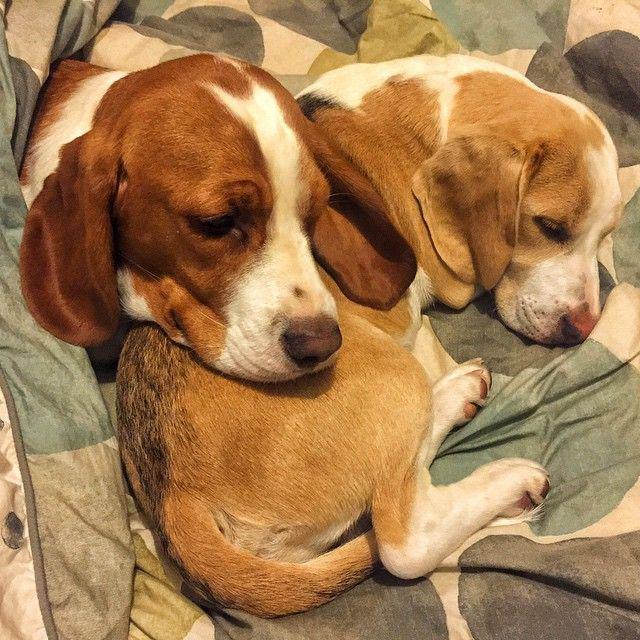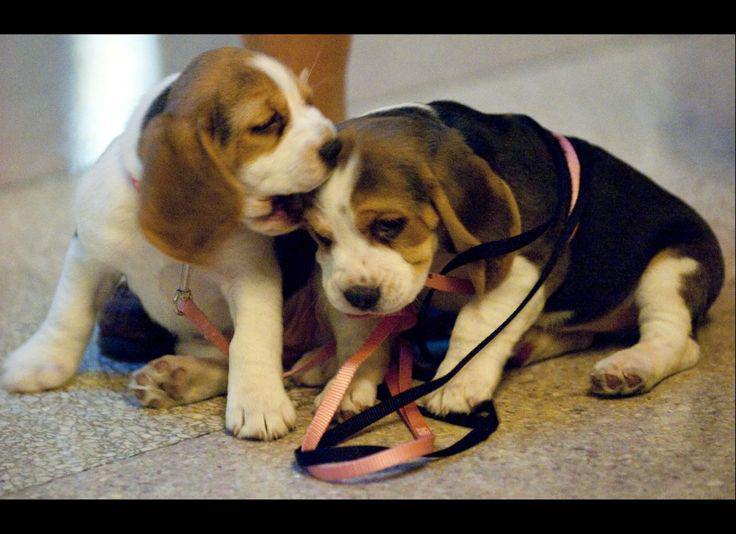The first image is the image on the left, the second image is the image on the right. Considering the images on both sides, is "One puppy is holding a stuffed animal." valid? Answer yes or no. No. The first image is the image on the left, the second image is the image on the right. Evaluate the accuracy of this statement regarding the images: "In one image a dog lying on its side has a front leg over a stuffed animal which it has pulled close, while in a second image, at least two dogs are sleeping.". Is it true? Answer yes or no. No. 